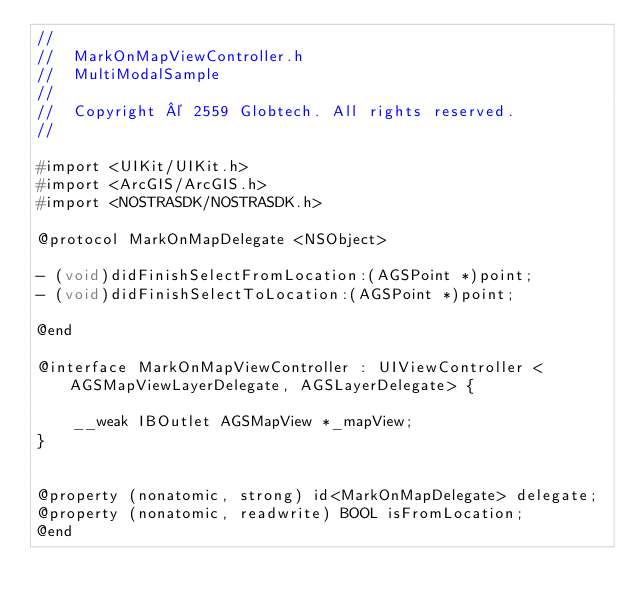<code> <loc_0><loc_0><loc_500><loc_500><_C_>//
//  MarkOnMapViewController.h
//  MultiModalSample
//
//  Copyright © 2559 Globtech. All rights reserved.
//

#import <UIKit/UIKit.h>
#import <ArcGIS/ArcGIS.h>
#import <NOSTRASDK/NOSTRASDK.h>

@protocol MarkOnMapDelegate <NSObject>

- (void)didFinishSelectFromLocation:(AGSPoint *)point;
- (void)didFinishSelectToLocation:(AGSPoint *)point;

@end

@interface MarkOnMapViewController : UIViewController <AGSMapViewLayerDelegate, AGSLayerDelegate> {
    
    __weak IBOutlet AGSMapView *_mapView;
}


@property (nonatomic, strong) id<MarkOnMapDelegate> delegate;
@property (nonatomic, readwrite) BOOL isFromLocation;
@end
</code> 